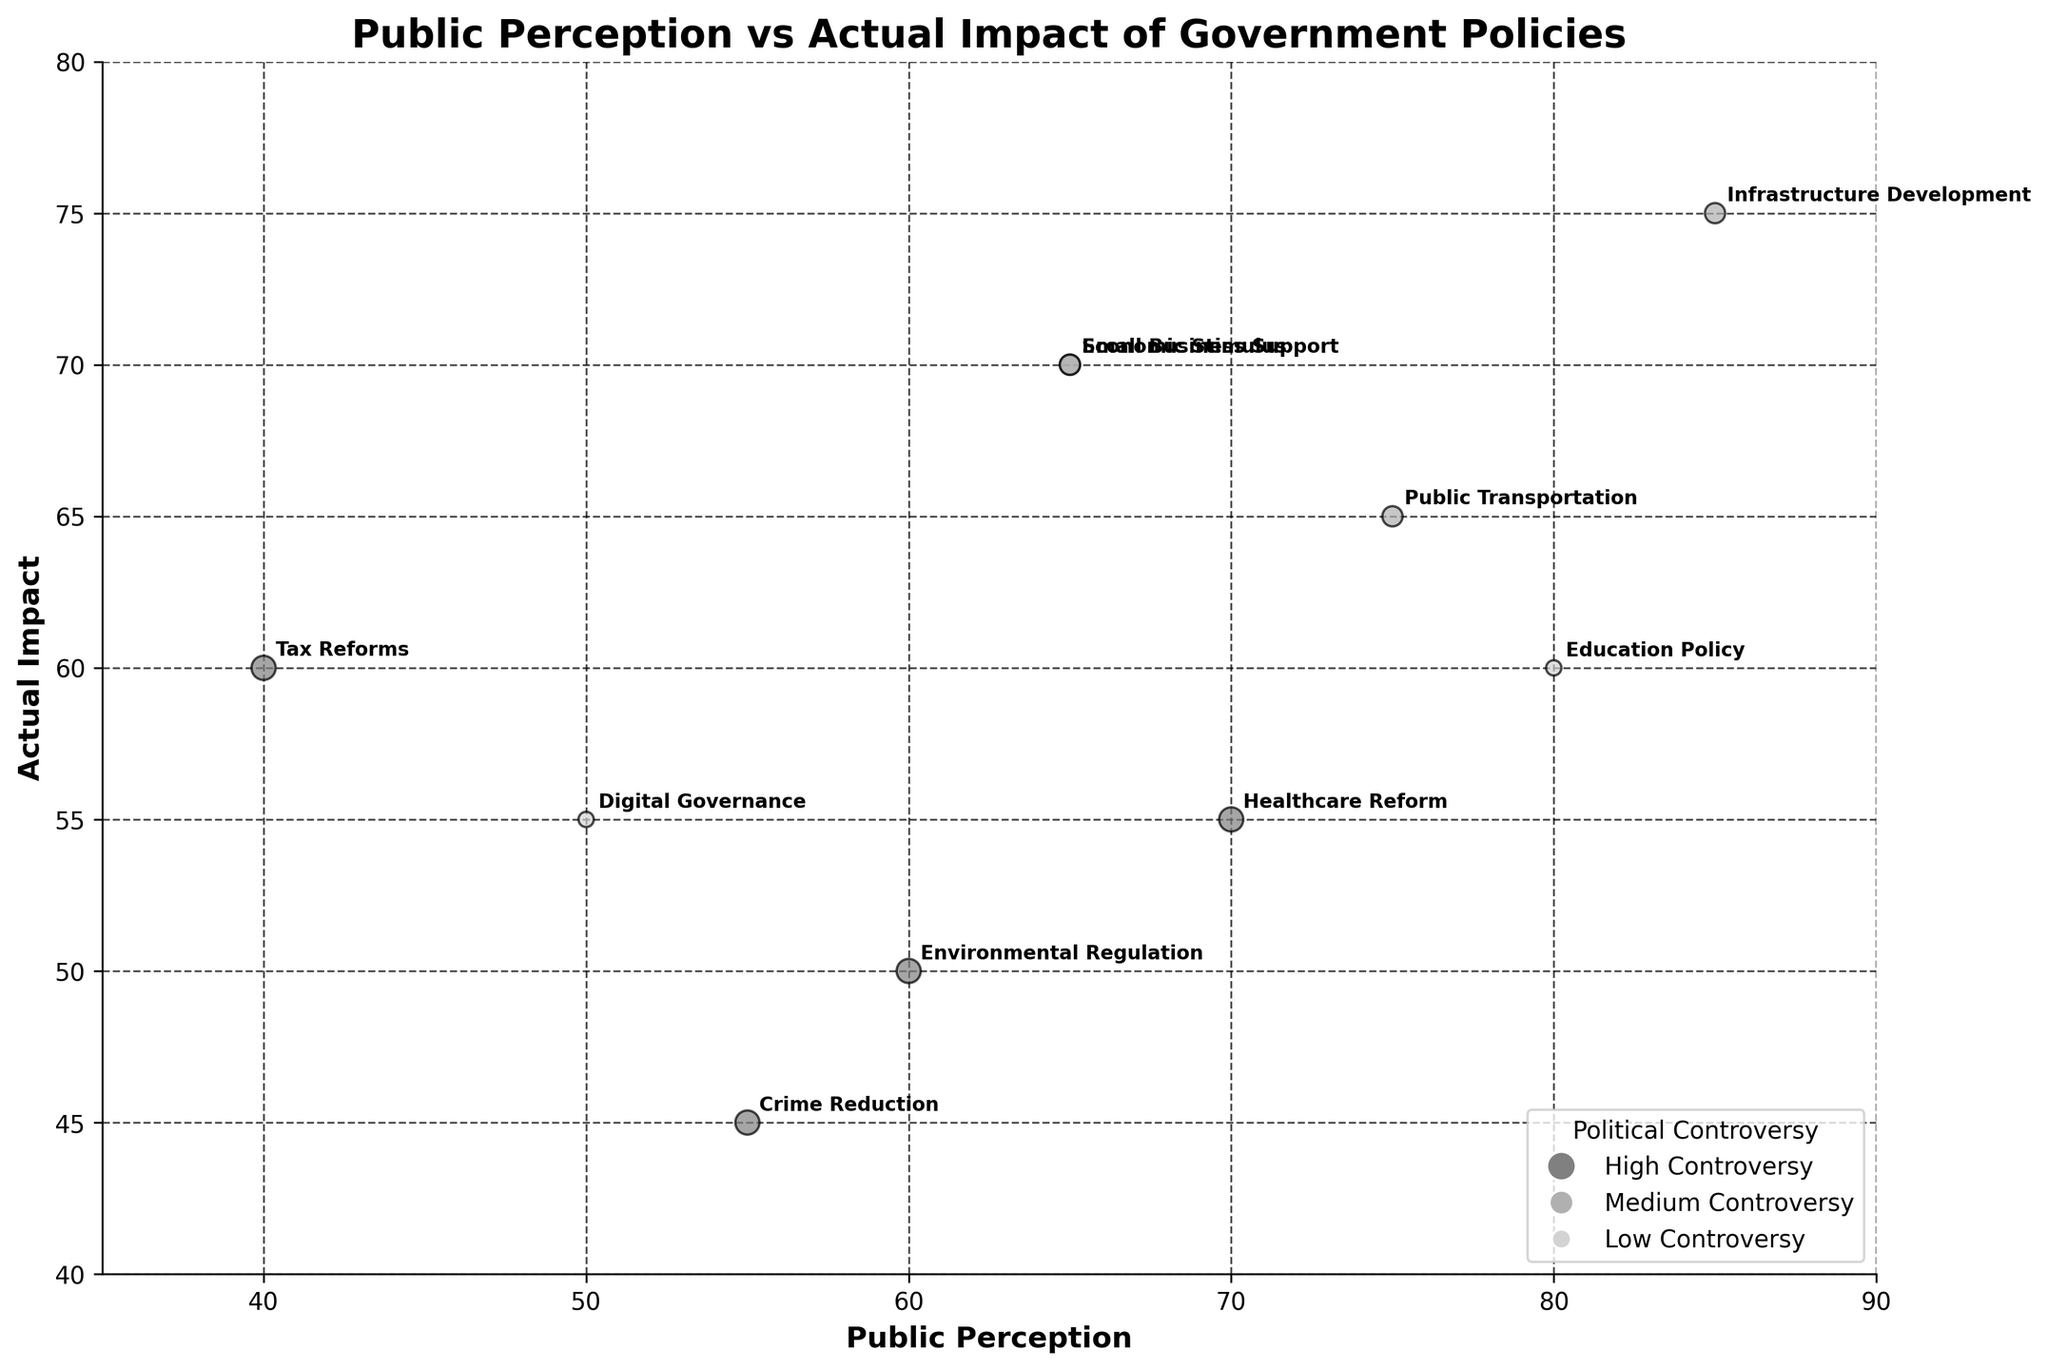What is the title of the bubble chart? The title of the bubble chart is prominently displayed at the top. It reads "Public Perception vs Actual Impact of Government Policies"
Answer: Public Perception vs Actual Impact of Government Policies Which policy has the highest public perception score? The policy labeled with an "85" on the x-axis has the highest public perception score, which is Infrastructure Development
Answer: Infrastructure Development What is the actual impact score for Digital Governance? Locate Digital Governance on the chart and refer to its position on the y-axis. This policy is marked with a "55".
Answer: 55 How many policies fall into the high political controversy category? High political controversy policies are represented by the largest bubble size and darkest color. Counting these, we have Healthcare Reform, Environmental Regulation, Crime Reduction, and Tax Reforms.
Answer: 4 Which policy has the greatest discrepancy between public perception and actual impact? Calculate the difference between x and y values for each policy. Healthcare Reform has a score of 70 (Public Perception) and 55 (Actual Impact), a difference of 15, which is the largest discrepancy.
Answer: Healthcare Reform Compare the public perception scores of Economic Stimulus and Small Business Support. Which one is higher? Economic Stimulus is marked with a score of 65 on the x-axis, and Small Business Support is also marked with 65. Therefore, both have the same public perception scores.
Answer: Both are equal Which policy has the lowest actual impact score, and what is its public perception value? Identify the policy with the lowest position on the y-axis. Crime Reduction has the lowest actual impact score of 45, with a public perception value of 55.
Answer: Crime Reduction, 55 Sort the policies by the order of their public perception scores in ascending order. Starting from the lowest public perception score on the x-axis: Tax Reforms (40), Digital Governance (50), Crime Reduction (55), Environmental Regulation (60), Small Business Support (65), Economic Stimulus (65), Public Transportation (75), Education Policy (80), Infrastructure Development (85)
Answer: Tax Reforms, Digital Governance, Crime Reduction, Environmental Regulation, Small Business Support, Economic Stimulus, Public Transportation, Education Policy, Infrastructure Development Given the public perception is 75, what is the actual impact score for Public Transportation? Find the bubble on the x-axis for 75 and look at its corresponding y-axis value. Public Transportation is marked by a score of 65 on the y-axis.
Answer: 65 Which policy has both public perception and actual impact scores closest to each other, and what are the scores? Identify the smallest difference between x and y values. Digital Governance has scores of 50 (Public Perception) and 55 (Actual Impact), with a difference of 5, the closest match.
Answer: Digital Governance, 50 and 55 